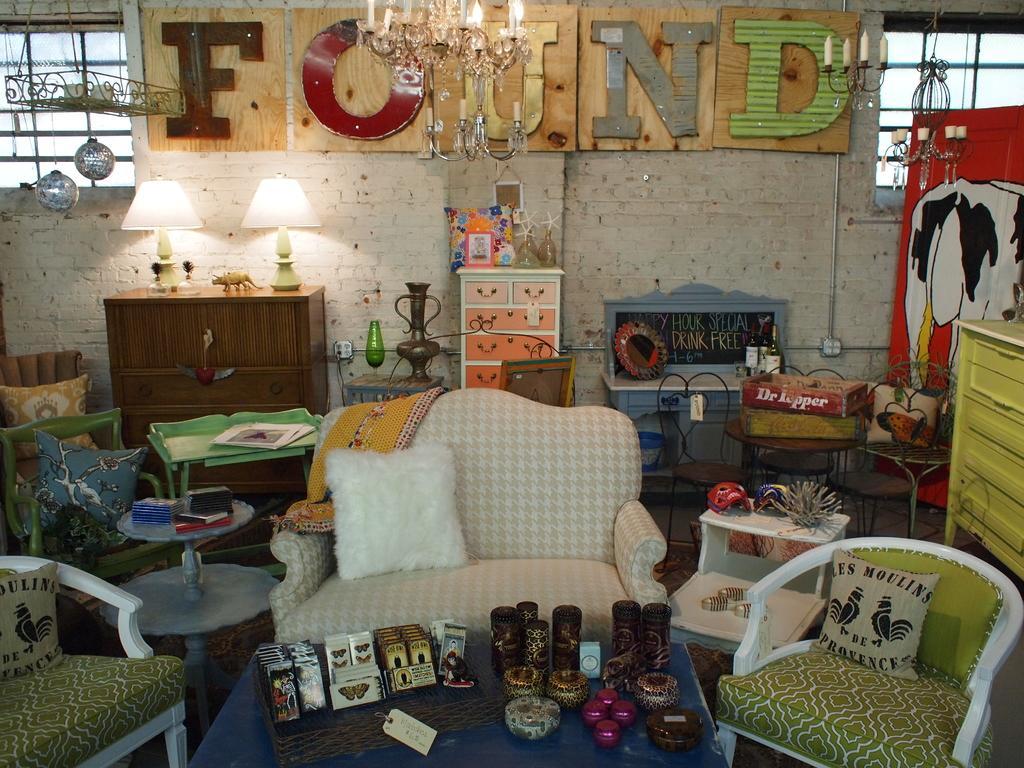Can you describe this image briefly? In this picture there is a sofa and two chairs, there is also table in front of the sofa. There are drawers and shelves and cupboards. There is a plant into the right. 